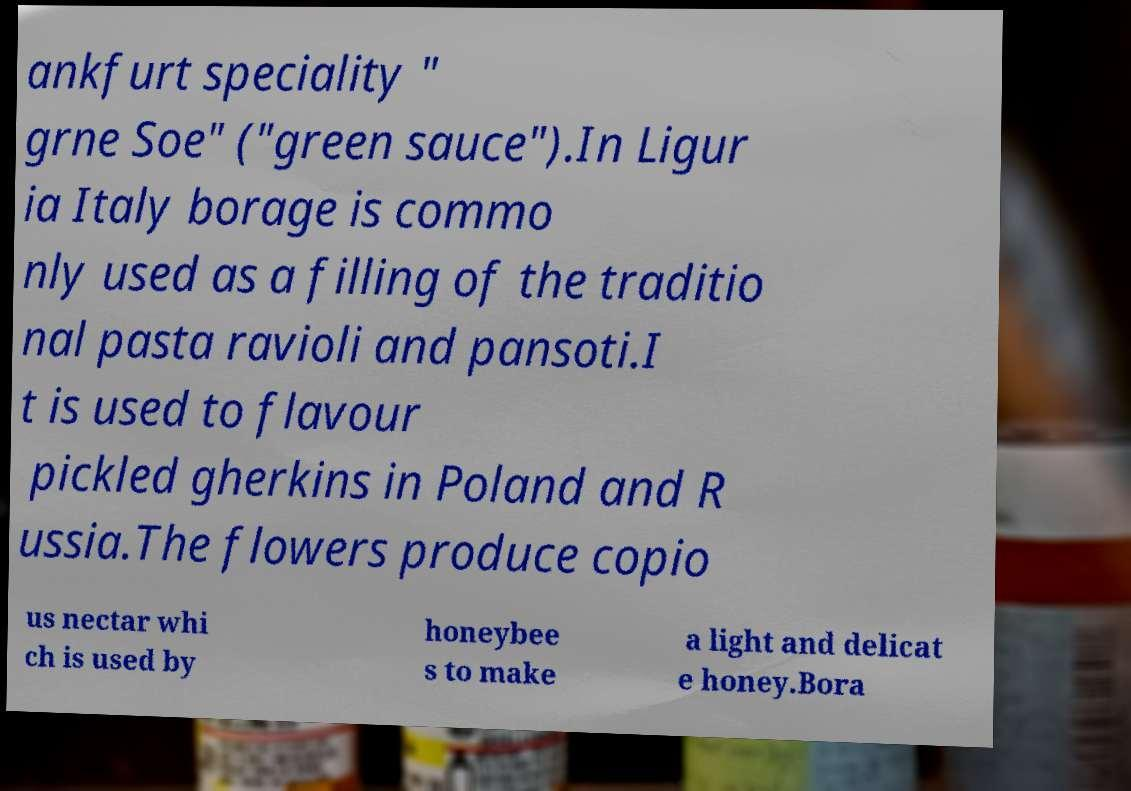Please read and relay the text visible in this image. What does it say? ankfurt speciality " grne Soe" ("green sauce").In Ligur ia Italy borage is commo nly used as a filling of the traditio nal pasta ravioli and pansoti.I t is used to flavour pickled gherkins in Poland and R ussia.The flowers produce copio us nectar whi ch is used by honeybee s to make a light and delicat e honey.Bora 